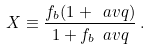Convert formula to latex. <formula><loc_0><loc_0><loc_500><loc_500>X \equiv \frac { f _ { b } ( 1 + \ a v q ) } { 1 + f _ { b } \ a v q } \, .</formula> 